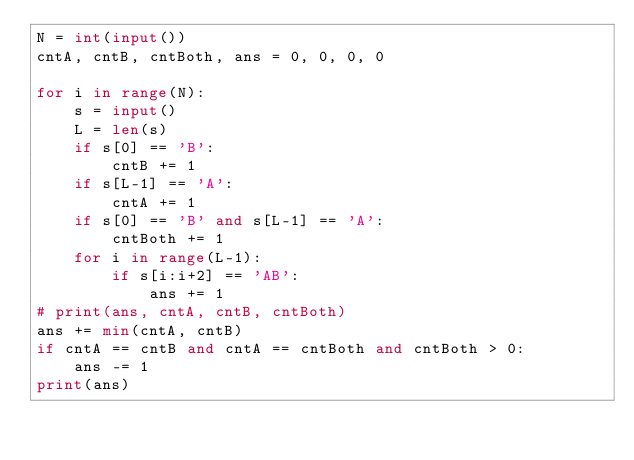Convert code to text. <code><loc_0><loc_0><loc_500><loc_500><_Python_>N = int(input())
cntA, cntB, cntBoth, ans = 0, 0, 0, 0

for i in range(N):
    s = input()
    L = len(s)
    if s[0] == 'B':
        cntB += 1
    if s[L-1] == 'A':
        cntA += 1
    if s[0] == 'B' and s[L-1] == 'A':
        cntBoth += 1
    for i in range(L-1):
        if s[i:i+2] == 'AB':
            ans += 1
# print(ans, cntA, cntB, cntBoth)
ans += min(cntA, cntB)
if cntA == cntB and cntA == cntBoth and cntBoth > 0:
    ans -= 1
print(ans)
</code> 